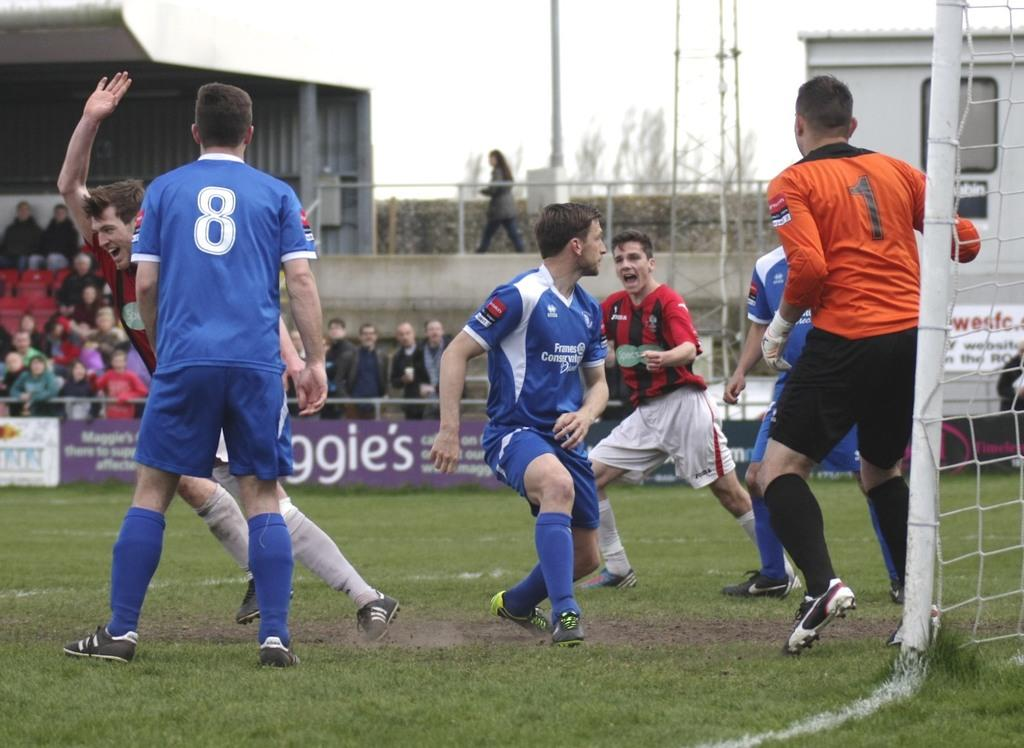<image>
Relay a brief, clear account of the picture shown. The soccer player on the left has the number 8 on his jersey. 